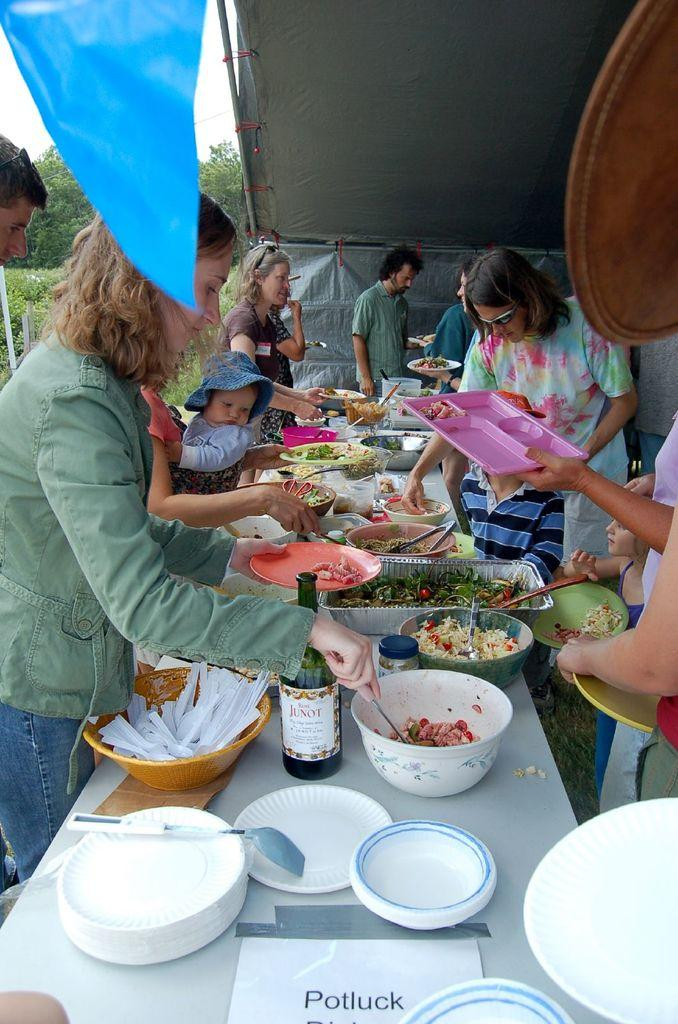What is happening in the image? There is a group of people in the image, and they are standing. What are the people doing while standing? The people are serving food in their plates. What page of the book are the people reading in the image? There is no book or page visible in the image; the people are serving food in their plates. 